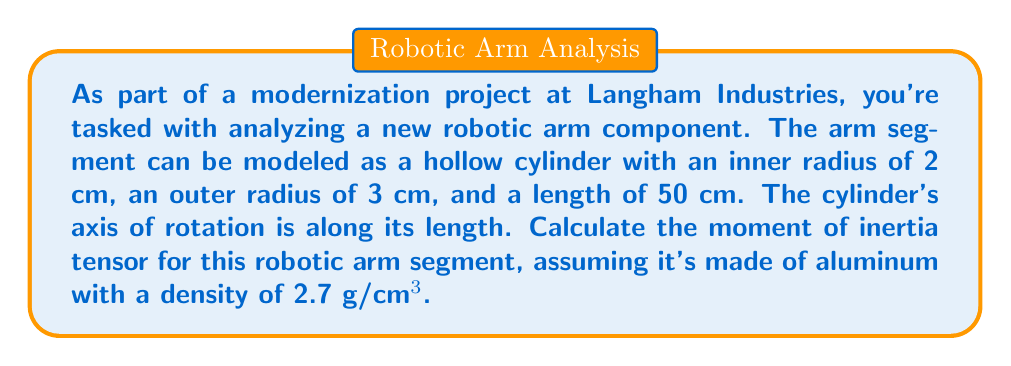Provide a solution to this math problem. To solve this problem, we'll follow these steps:

1) First, recall the moment of inertia tensor for a hollow cylinder rotating about its central axis:

$$I = \begin{pmatrix}
I_{xx} & 0 & 0 \\
0 & I_{yy} & 0 \\
0 & 0 & I_{zz}
\end{pmatrix}$$

Where:
$I_{xx} = I_{yy} = \frac{1}{4}m(r_1^2 + r_2^2) + \frac{1}{12}ml^2$
$I_{zz} = \frac{1}{2}m(r_1^2 + r_2^2)$

2) Calculate the mass of the cylinder:
$V = \pi(r_2^2 - r_1^2)l = \pi((3\text{ cm})^2 - (2\text{ cm})^2)(50\text{ cm}) = 785\pi\text{ cm}^3$
$m = \rho V = (2.7\text{ g/cm}^3)(785\pi\text{ cm}^3) = 2119.5\pi\text{ g} \approx 6.66\text{ kg}$

3) Calculate $I_{xx}$ and $I_{yy}$:
$$\begin{align*}
I_{xx} &= I_{yy} = \frac{1}{4}m(r_1^2 + r_2^2) + \frac{1}{12}ml^2 \\
&= \frac{1}{4}(6.66)(2^2 + 3^2) + \frac{1}{12}(6.66)(50^2) \\
&= 20.825 + 138.75 \\
&= 159.575\text{ kg}\cdot\text{cm}^2 \\
&= 0.0159575\text{ kg}\cdot\text{m}^2
\end{align*}$$

4) Calculate $I_{zz}$:
$$\begin{align*}
I_{zz} &= \frac{1}{2}m(r_1^2 + r_2^2) \\
&= \frac{1}{2}(6.66)(2^2 + 3^2) \\
&= 41.65\text{ kg}\cdot\text{cm}^2 \\
&= 0.004165\text{ kg}\cdot\text{m}^2
\end{align*}$$

5) Construct the moment of inertia tensor:

$$I = \begin{pmatrix}
0.0159575 & 0 & 0 \\
0 & 0.0159575 & 0 \\
0 & 0 & 0.004165
\end{pmatrix}\text{ kg}\cdot\text{m}^2$$
Answer: $$I = \begin{pmatrix}
0.0159575 & 0 & 0 \\
0 & 0.0159575 & 0 \\
0 & 0 & 0.004165
\end{pmatrix}\text{ kg}\cdot\text{m}^2$$ 